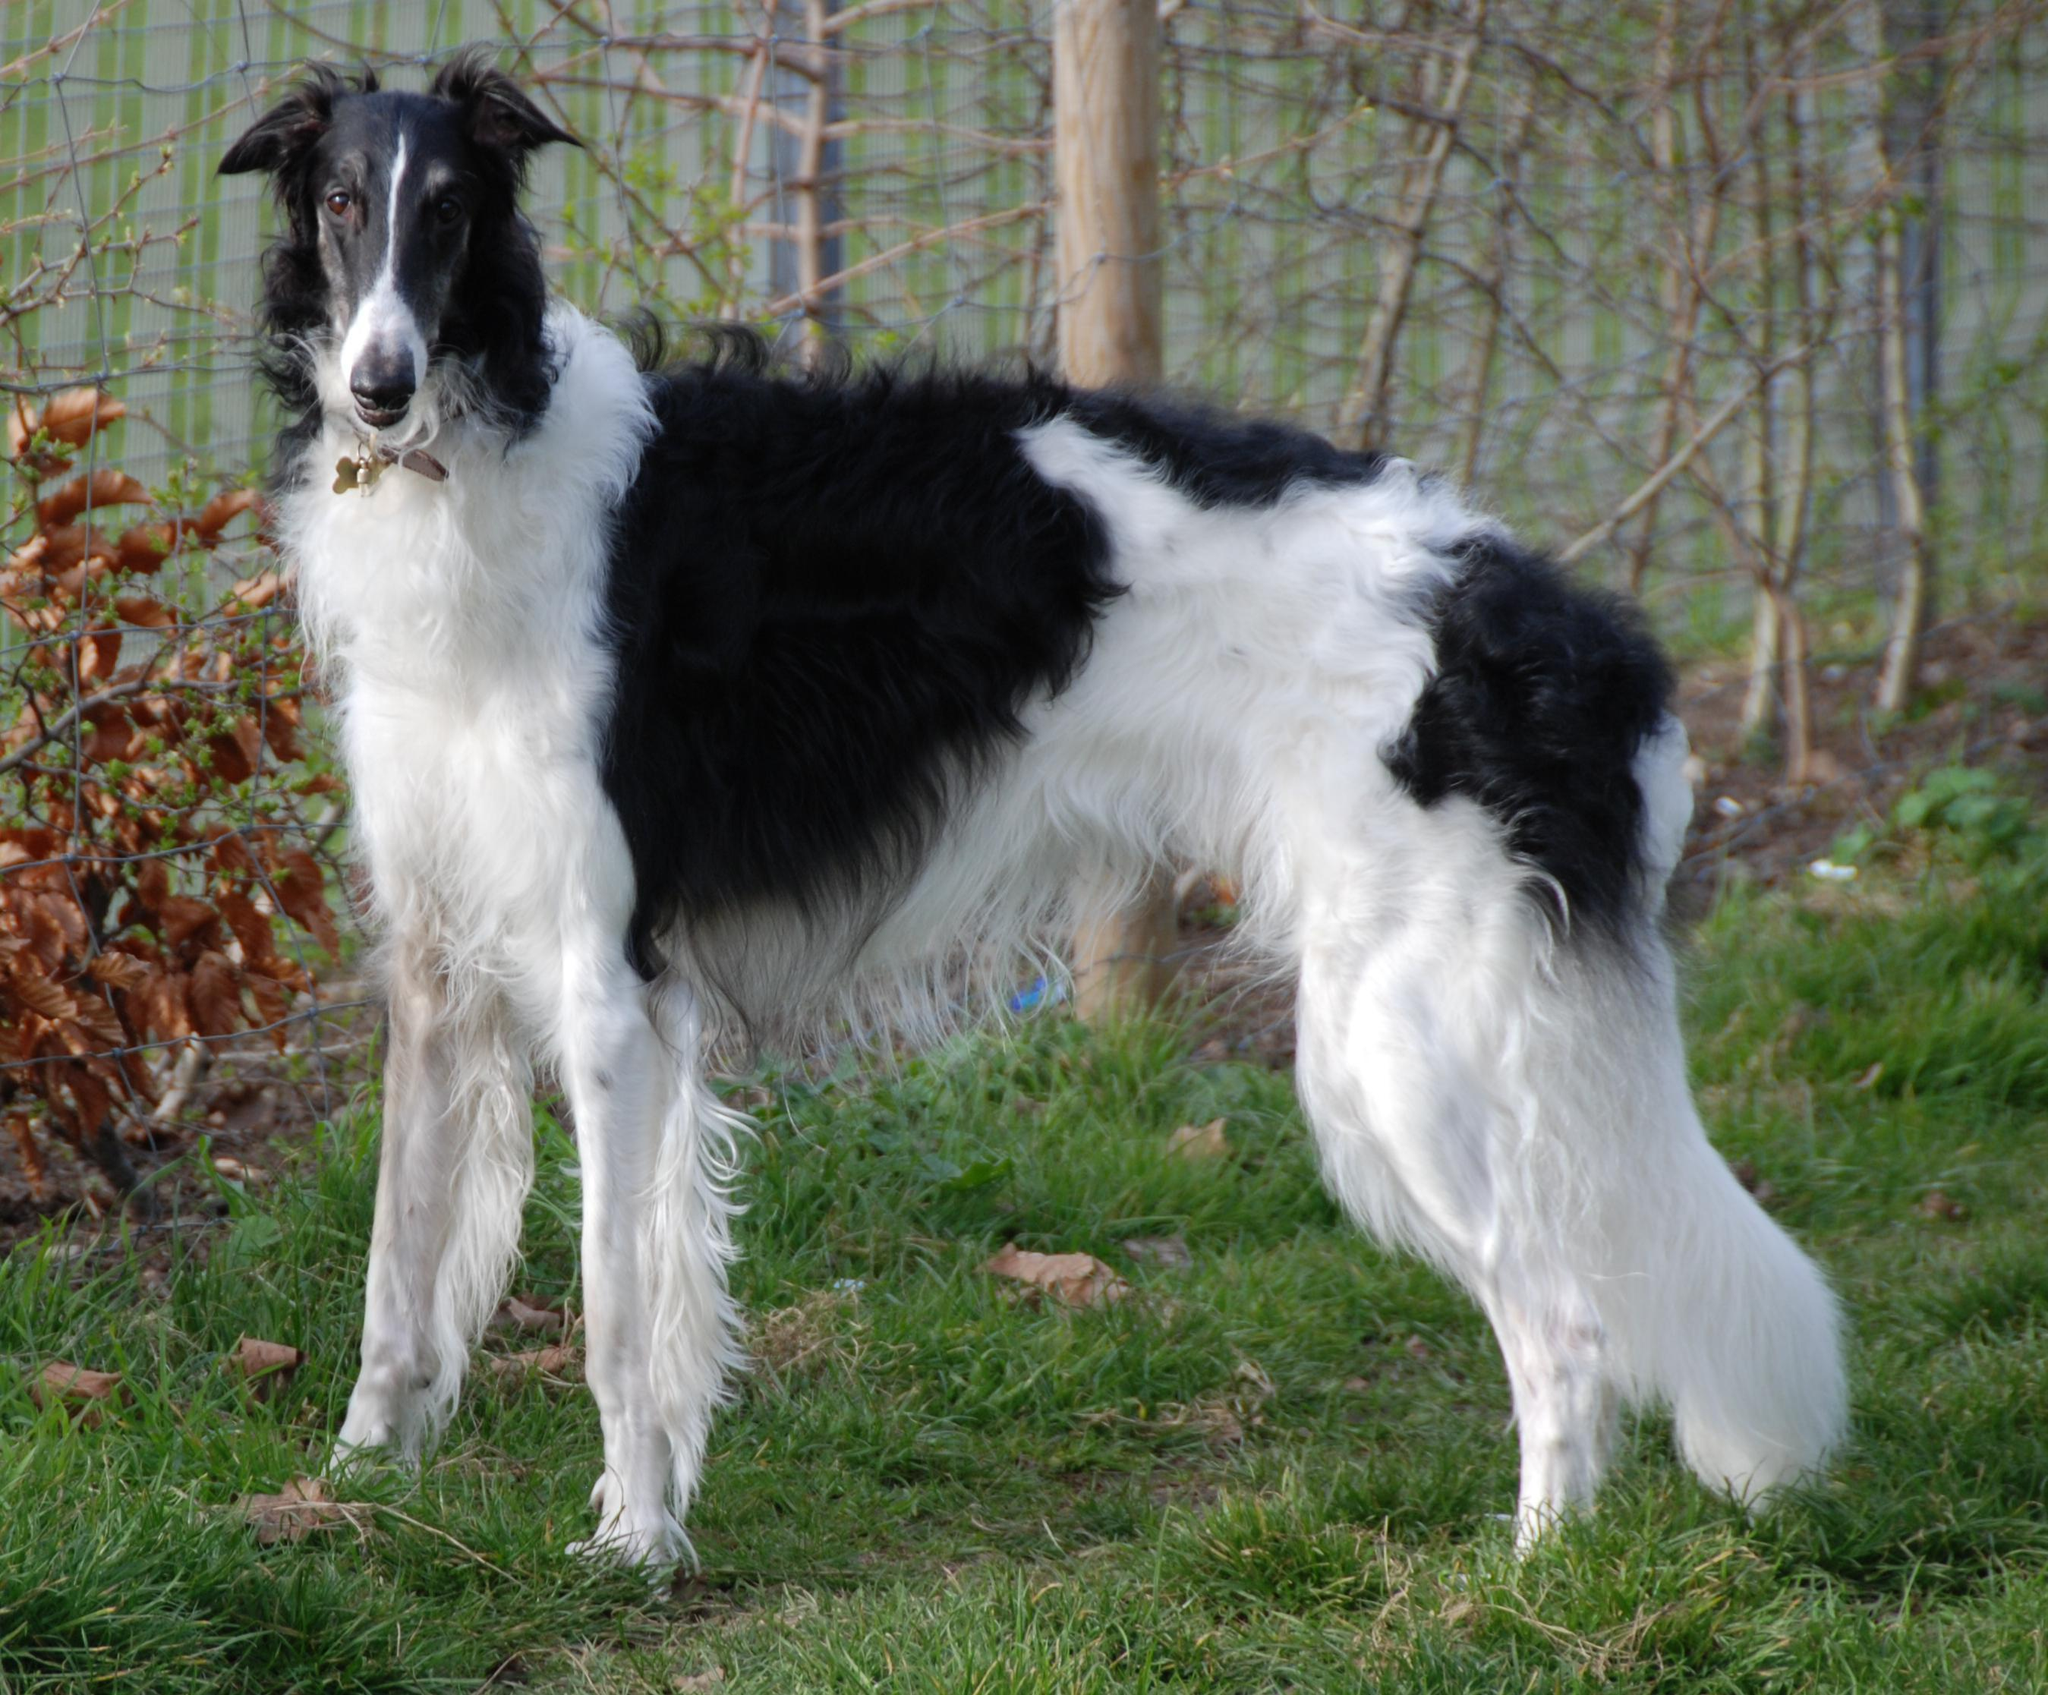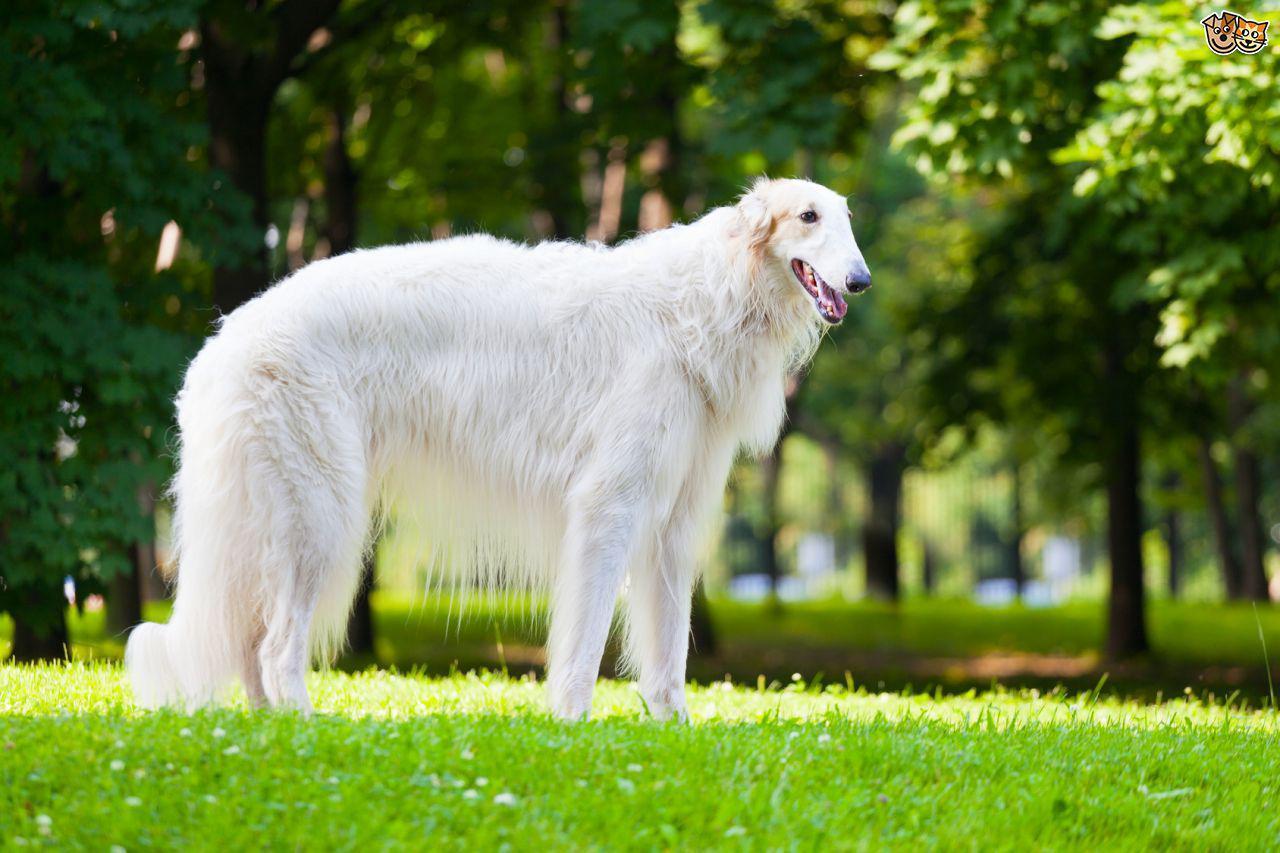The first image is the image on the left, the second image is the image on the right. For the images displayed, is the sentence "There are no more than 2 dogs per image pair" factually correct? Answer yes or no. Yes. The first image is the image on the left, the second image is the image on the right. For the images displayed, is the sentence "In one of the images, a single white dog with no dark patches has its mouth open and is standing in green grass facing rightward." factually correct? Answer yes or no. Yes. The first image is the image on the left, the second image is the image on the right. For the images displayed, is the sentence "There is a human holding a dog's leash." factually correct? Answer yes or no. No. 